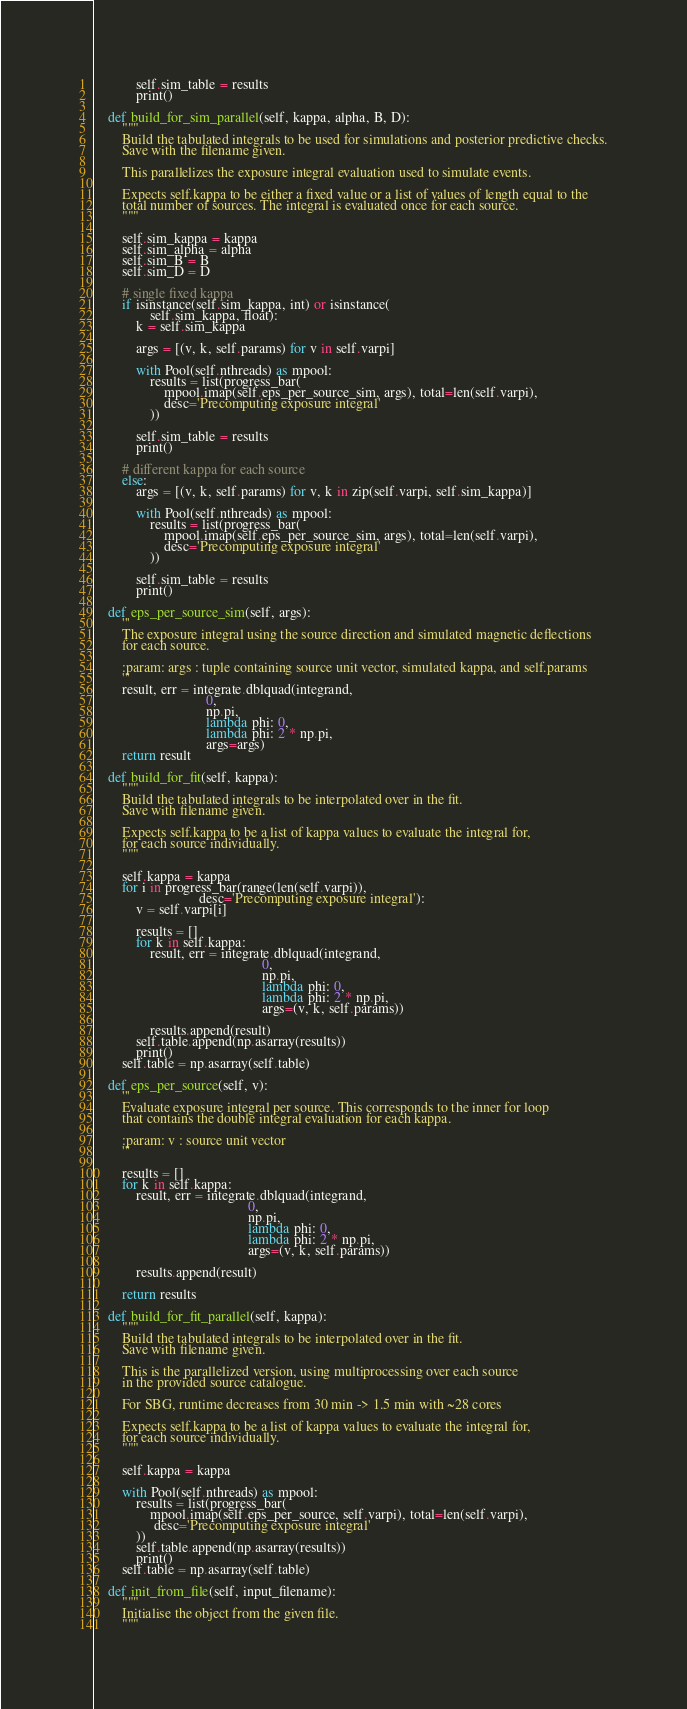Convert code to text. <code><loc_0><loc_0><loc_500><loc_500><_Python_>
            self.sim_table = results
            print()

    def build_for_sim_parallel(self, kappa, alpha, B, D):
        """
        Build the tabulated integrals to be used for simulations and posterior predictive checks.
        Save with the filename given.

        This parallelizes the exposure integral evaluation used to simulate events.
        
        Expects self.kappa to be either a fixed value or a list of values of length equal to the 
        total number of sources. The integral is evaluated once for each source. 
        """

        self.sim_kappa = kappa
        self.sim_alpha = alpha
        self.sim_B = B
        self.sim_D = D

        # single fixed kappa
        if isinstance(self.sim_kappa, int) or isinstance(
                self.sim_kappa, float):
            k = self.sim_kappa

            args = [(v, k, self.params) for v in self.varpi]

            with Pool(self.nthreads) as mpool:
                results = list(progress_bar(
                    mpool.imap(self.eps_per_source_sim, args), total=len(self.varpi),
                    desc='Precomputing exposure integral'
                ))           

            self.sim_table = results
            print()

        # different kappa for each source
        else:
            args = [(v, k, self.params) for v, k in zip(self.varpi, self.sim_kappa)]

            with Pool(self.nthreads) as mpool:
                results = list(progress_bar(
                    mpool.imap(self.eps_per_source_sim, args), total=len(self.varpi),
                    desc='Precomputing exposure integral'
                ))           
                
            self.sim_table = results
            print()

    def eps_per_source_sim(self, args):
        '''
        The exposure integral using the source direction and simulated magnetic deflections
        for each source. 

        :param: args : tuple containing source unit vector, simulated kappa, and self.params
        '''
        result, err = integrate.dblquad(integrand,
                                0,
                                np.pi,
                                lambda phi: 0,
                                lambda phi: 2 * np.pi,
                                args=args)
        return result

    def build_for_fit(self, kappa):
        """
        Build the tabulated integrals to be interpolated over in the fit.
        Save with filename given.
        
        Expects self.kappa to be a list of kappa values to evaluate the integral for, 
        for each source individually.
        """

        self.kappa = kappa
        for i in progress_bar(range(len(self.varpi)),
                              desc='Precomputing exposure integral'):
            v = self.varpi[i]

            results = []
            for k in self.kappa:
                result, err = integrate.dblquad(integrand,
                                                0,
                                                np.pi,
                                                lambda phi: 0,
                                                lambda phi: 2 * np.pi,
                                                args=(v, k, self.params))

                results.append(result)
            self.table.append(np.asarray(results))
            print()
        self.table = np.asarray(self.table)

    def eps_per_source(self, v):
        '''
        Evaluate exposure integral per source. This corresponds to the inner for loop
        that contains the double integral evaluation for each kappa.

        :param: v : source unit vector
        '''

        results = []
        for k in self.kappa:
            result, err = integrate.dblquad(integrand,
                                            0,
                                            np.pi,
                                            lambda phi: 0,
                                            lambda phi: 2 * np.pi,
                                            args=(v, k, self.params))

            results.append(result)

        return results

    def build_for_fit_parallel(self, kappa):
        """
        Build the tabulated integrals to be interpolated over in the fit.
        Save with filename given.

        This is the parallelized version, using multiprocessing over each source
        in the provided source catalogue.

        For SBG, runtime decreases from 30 min -> 1.5 min with ~28 cores
        
        Expects self.kappa to be a list of kappa values to evaluate the integral for, 
        for each source individually.
        """

        self.kappa = kappa

        with Pool(self.nthreads) as mpool:
            results = list(progress_bar(
                mpool.imap(self.eps_per_source, self.varpi), total=len(self.varpi),
                 desc='Precomputing exposure integral'
            ))
            self.table.append(np.asarray(results))
            print()
        self.table = np.asarray(self.table)

    def init_from_file(self, input_filename):
        """
        Initialise the object from the given file.
        """
</code> 